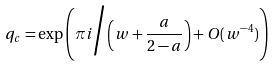<formula> <loc_0><loc_0><loc_500><loc_500>q _ { c } = \exp \left ( \pi i \Big / \left ( w + \frac { a } { 2 - a } \right ) + O ( w ^ { - 4 } ) \right )</formula> 